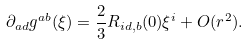<formula> <loc_0><loc_0><loc_500><loc_500>\partial _ { a d } g ^ { a b } ( \xi ) = \frac { 2 } { 3 } R _ { i d , b } ( 0 ) \xi ^ { i } + O ( r ^ { 2 } ) .</formula> 